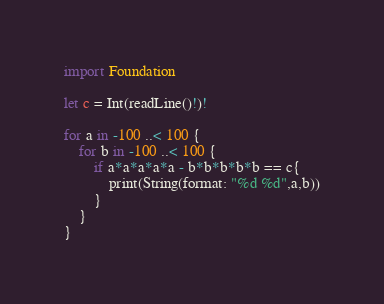<code> <loc_0><loc_0><loc_500><loc_500><_Swift_>import Foundation

let c = Int(readLine()!)!

for a in -100 ..< 100 {
    for b in -100 ..< 100 {
        if a*a*a*a*a - b*b*b*b*b == c{
            print(String(format: "%d %d",a,b))
        }
    }
}</code> 